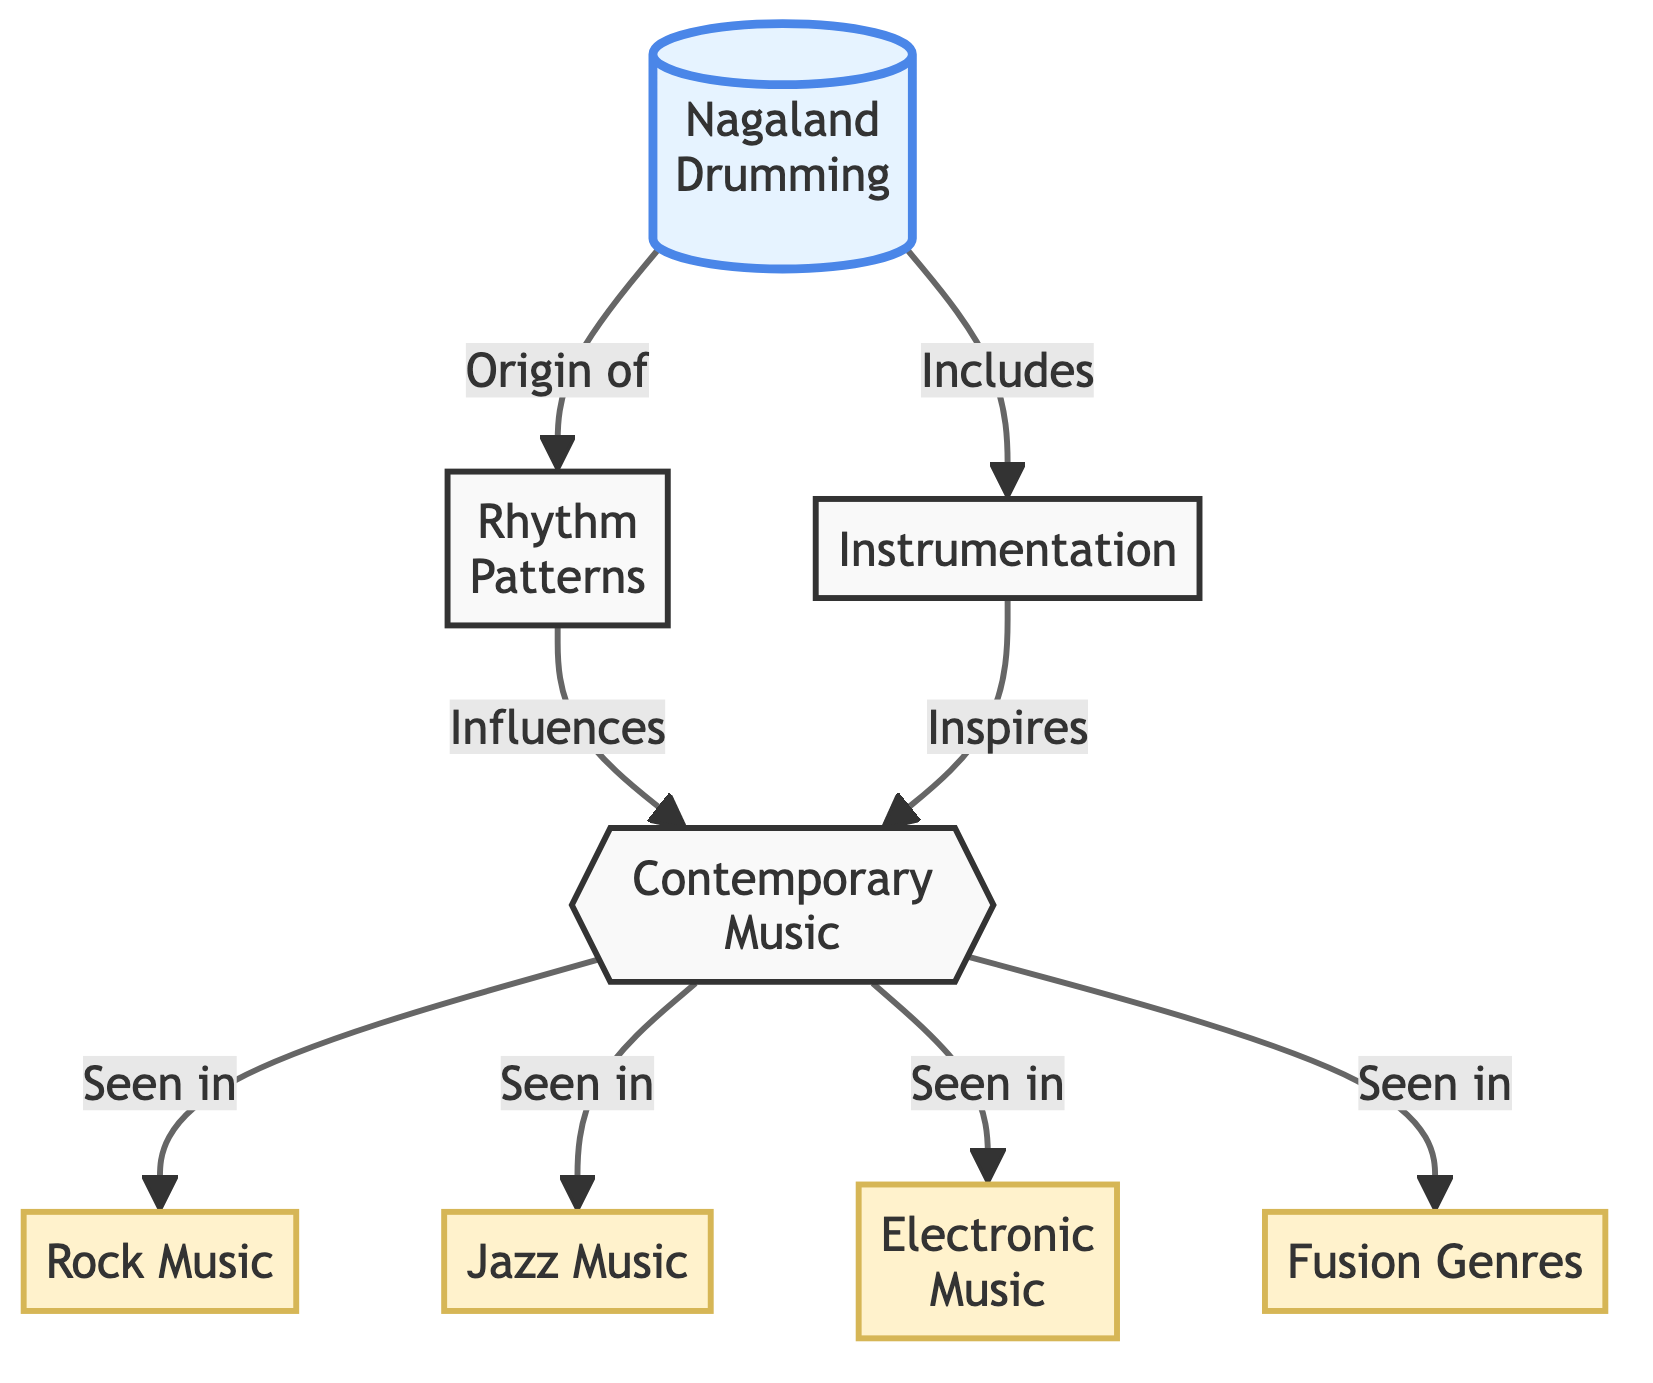What is the main subject of the diagram? The main subject of the diagram is "Nagaland Drumming," which is prominently placed at the top of the diagram.
Answer: Nagaland Drumming How many contemporary music genres are influenced by Nagaland Drumming? The diagram lists four contemporary music genres: Rock Music, Jazz Music, Electronic Music, and Fusion Genres. The answer is derived from the connections leading to these genres from "Contemporary Music."
Answer: Four What is the relationship between "Rhythm Patterns" and "Contemporary Music"? "Rhythm Patterns" influences "Contemporary Music," as indicated by the directed link between them in the diagram.
Answer: Influences Which component of Nagaland Drumming is directly linked to "Instrumentation"? The component directly linked to "Instrumentation" from Nagaland Drumming is shown as "Includes," indicating that instrumentation is part of Nagaland Drumming's characteristics.
Answer: Includes How does "Instrumentation" interact with "Contemporary Music"? "Instrumentation" inspires "Contemporary Music," as reflected by the directed link from "Instrumentation" to "Contemporary Music" in the diagram.
Answer: Inspires What type of flowchart is used for this diagram? The diagram is a flowchart, as indicated by its structure showcasing the flow of information and relationships between different components and genres.
Answer: Flowchart Which genre is not explicitly listed as influenced by "Contemporary Music"? The only implied genre that does not appear explicitly in the diagram is "Classical Music," since it is not part of the nodes connected to "Contemporary Music."
Answer: Classical Music What does the double curly braces indicate in the diagram? The double curly braces surrounding "Contemporary Music" signify that it's a central concept affected by both Rhythm Patterns and Instrumentation, representing its importance in the flowchart.
Answer: Central concept How many edges connect "Contemporary Music" to the genres listed? There are four edges that connect "Contemporary Music" to the genres listed: Rock Music, Jazz Music, Electronic Music, and Fusion Genres. Thus, the total count of edges is four.
Answer: Four 